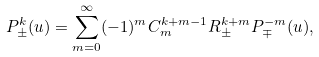Convert formula to latex. <formula><loc_0><loc_0><loc_500><loc_500>P ^ { k } _ { \pm } ( u ) = \sum _ { m = 0 } ^ { \infty } ( - 1 ) ^ { m } C ^ { k + m - 1 } _ { m } R ^ { k + m } _ { \pm } P ^ { - m } _ { \mp } ( u ) ,</formula> 